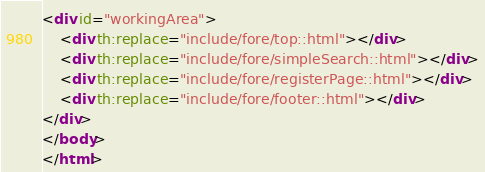Convert code to text. <code><loc_0><loc_0><loc_500><loc_500><_HTML_><div id="workingArea">
    <div th:replace="include/fore/top::html"></div>
    <div th:replace="include/fore/simpleSearch::html"></div>
    <div th:replace="include/fore/registerPage::html"></div>
    <div th:replace="include/fore/footer::html"></div>
</div>
</body>
</html></code> 